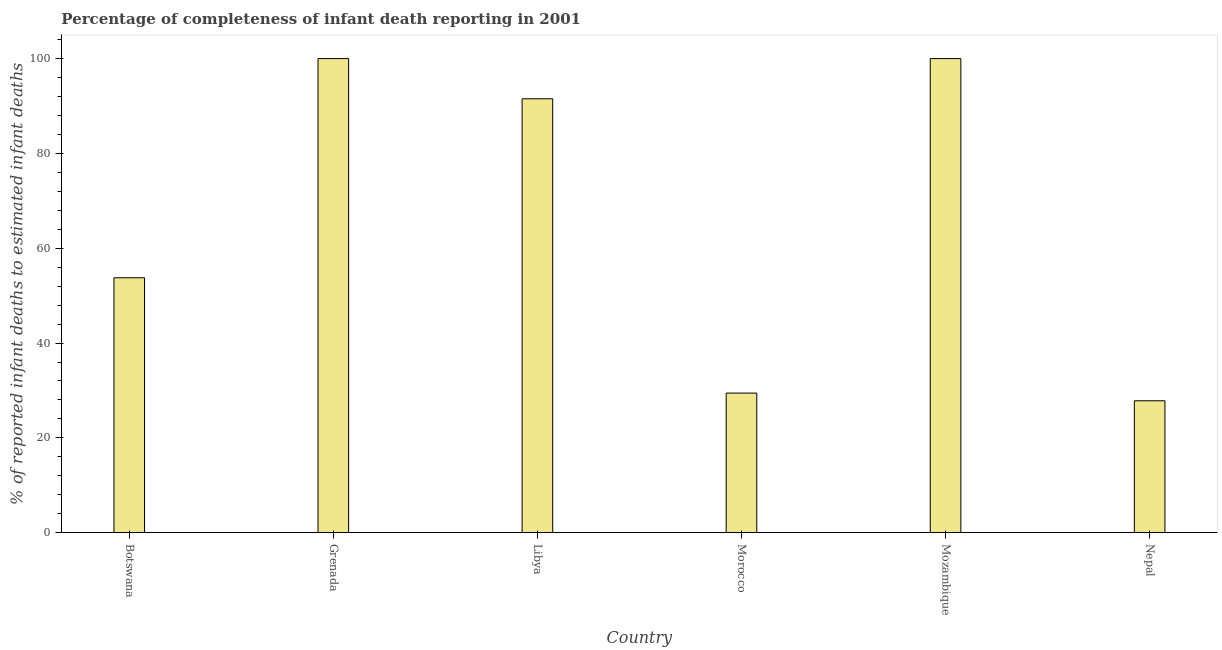Does the graph contain grids?
Make the answer very short. No. What is the title of the graph?
Keep it short and to the point. Percentage of completeness of infant death reporting in 2001. What is the label or title of the X-axis?
Give a very brief answer. Country. What is the label or title of the Y-axis?
Keep it short and to the point. % of reported infant deaths to estimated infant deaths. What is the completeness of infant death reporting in Nepal?
Make the answer very short. 27.82. Across all countries, what is the maximum completeness of infant death reporting?
Your answer should be compact. 100. Across all countries, what is the minimum completeness of infant death reporting?
Keep it short and to the point. 27.82. In which country was the completeness of infant death reporting maximum?
Provide a succinct answer. Grenada. In which country was the completeness of infant death reporting minimum?
Give a very brief answer. Nepal. What is the sum of the completeness of infant death reporting?
Keep it short and to the point. 402.56. What is the difference between the completeness of infant death reporting in Grenada and Nepal?
Provide a short and direct response. 72.17. What is the average completeness of infant death reporting per country?
Your response must be concise. 67.09. What is the median completeness of infant death reporting?
Keep it short and to the point. 72.64. In how many countries, is the completeness of infant death reporting greater than 96 %?
Keep it short and to the point. 2. What is the ratio of the completeness of infant death reporting in Morocco to that in Mozambique?
Keep it short and to the point. 0.29. Is the completeness of infant death reporting in Grenada less than that in Mozambique?
Your response must be concise. No. Is the difference between the completeness of infant death reporting in Botswana and Nepal greater than the difference between any two countries?
Provide a succinct answer. No. What is the difference between the highest and the second highest completeness of infant death reporting?
Your answer should be very brief. 0. What is the difference between the highest and the lowest completeness of infant death reporting?
Keep it short and to the point. 72.18. In how many countries, is the completeness of infant death reporting greater than the average completeness of infant death reporting taken over all countries?
Offer a very short reply. 3. How many countries are there in the graph?
Offer a very short reply. 6. What is the difference between two consecutive major ticks on the Y-axis?
Keep it short and to the point. 20. What is the % of reported infant deaths to estimated infant deaths of Botswana?
Keep it short and to the point. 53.77. What is the % of reported infant deaths to estimated infant deaths of Grenada?
Give a very brief answer. 100. What is the % of reported infant deaths to estimated infant deaths of Libya?
Keep it short and to the point. 91.52. What is the % of reported infant deaths to estimated infant deaths in Morocco?
Offer a terse response. 29.45. What is the % of reported infant deaths to estimated infant deaths of Nepal?
Your answer should be compact. 27.82. What is the difference between the % of reported infant deaths to estimated infant deaths in Botswana and Grenada?
Keep it short and to the point. -46.23. What is the difference between the % of reported infant deaths to estimated infant deaths in Botswana and Libya?
Ensure brevity in your answer.  -37.75. What is the difference between the % of reported infant deaths to estimated infant deaths in Botswana and Morocco?
Your answer should be compact. 24.32. What is the difference between the % of reported infant deaths to estimated infant deaths in Botswana and Mozambique?
Ensure brevity in your answer.  -46.23. What is the difference between the % of reported infant deaths to estimated infant deaths in Botswana and Nepal?
Offer a very short reply. 25.95. What is the difference between the % of reported infant deaths to estimated infant deaths in Grenada and Libya?
Provide a succinct answer. 8.48. What is the difference between the % of reported infant deaths to estimated infant deaths in Grenada and Morocco?
Provide a short and direct response. 70.55. What is the difference between the % of reported infant deaths to estimated infant deaths in Grenada and Mozambique?
Ensure brevity in your answer.  0. What is the difference between the % of reported infant deaths to estimated infant deaths in Grenada and Nepal?
Your answer should be compact. 72.18. What is the difference between the % of reported infant deaths to estimated infant deaths in Libya and Morocco?
Keep it short and to the point. 62.07. What is the difference between the % of reported infant deaths to estimated infant deaths in Libya and Mozambique?
Keep it short and to the point. -8.48. What is the difference between the % of reported infant deaths to estimated infant deaths in Libya and Nepal?
Your response must be concise. 63.69. What is the difference between the % of reported infant deaths to estimated infant deaths in Morocco and Mozambique?
Ensure brevity in your answer.  -70.55. What is the difference between the % of reported infant deaths to estimated infant deaths in Morocco and Nepal?
Give a very brief answer. 1.62. What is the difference between the % of reported infant deaths to estimated infant deaths in Mozambique and Nepal?
Your response must be concise. 72.18. What is the ratio of the % of reported infant deaths to estimated infant deaths in Botswana to that in Grenada?
Offer a very short reply. 0.54. What is the ratio of the % of reported infant deaths to estimated infant deaths in Botswana to that in Libya?
Provide a succinct answer. 0.59. What is the ratio of the % of reported infant deaths to estimated infant deaths in Botswana to that in Morocco?
Offer a very short reply. 1.83. What is the ratio of the % of reported infant deaths to estimated infant deaths in Botswana to that in Mozambique?
Offer a very short reply. 0.54. What is the ratio of the % of reported infant deaths to estimated infant deaths in Botswana to that in Nepal?
Make the answer very short. 1.93. What is the ratio of the % of reported infant deaths to estimated infant deaths in Grenada to that in Libya?
Provide a short and direct response. 1.09. What is the ratio of the % of reported infant deaths to estimated infant deaths in Grenada to that in Morocco?
Your answer should be very brief. 3.4. What is the ratio of the % of reported infant deaths to estimated infant deaths in Grenada to that in Nepal?
Keep it short and to the point. 3.59. What is the ratio of the % of reported infant deaths to estimated infant deaths in Libya to that in Morocco?
Offer a terse response. 3.11. What is the ratio of the % of reported infant deaths to estimated infant deaths in Libya to that in Mozambique?
Provide a succinct answer. 0.92. What is the ratio of the % of reported infant deaths to estimated infant deaths in Libya to that in Nepal?
Make the answer very short. 3.29. What is the ratio of the % of reported infant deaths to estimated infant deaths in Morocco to that in Mozambique?
Provide a succinct answer. 0.29. What is the ratio of the % of reported infant deaths to estimated infant deaths in Morocco to that in Nepal?
Ensure brevity in your answer.  1.06. What is the ratio of the % of reported infant deaths to estimated infant deaths in Mozambique to that in Nepal?
Your answer should be compact. 3.59. 